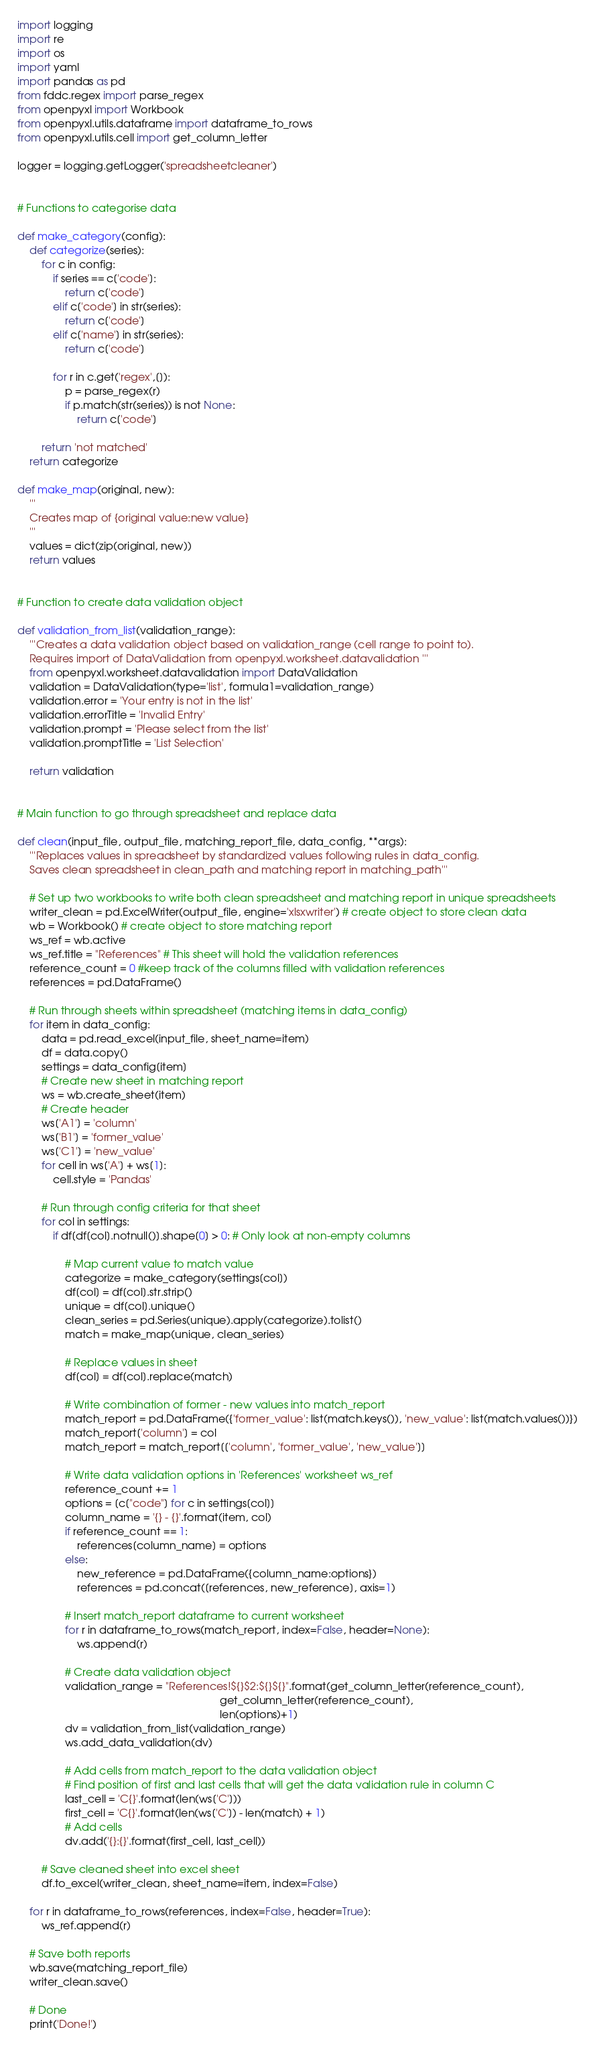<code> <loc_0><loc_0><loc_500><loc_500><_Python_>import logging
import re
import os
import yaml
import pandas as pd
from fddc.regex import parse_regex
from openpyxl import Workbook
from openpyxl.utils.dataframe import dataframe_to_rows
from openpyxl.utils.cell import get_column_letter

logger = logging.getLogger('spreadsheetcleaner')


# Functions to categorise data

def make_category(config):
    def categorize(series):
        for c in config:
            if series == c['code']:
                return c['code']
            elif c['code'] in str(series):
                return c['code']
            elif c['name'] in str(series):
                return c['code']

            for r in c.get('regex',[]):
                p = parse_regex(r)
                if p.match(str(series)) is not None:
                    return c['code']
                
        return 'not matched'
    return categorize

def make_map(original, new):
    '''
    Creates map of {original value:new value}
    '''
    values = dict(zip(original, new))
    return values


# Function to create data validation object

def validation_from_list(validation_range):
    '''Creates a data validation object based on validation_range (cell range to point to). 
    Requires import of DataValidation from openpyxl.worksheet.datavalidation '''
    from openpyxl.worksheet.datavalidation import DataValidation
    validation = DataValidation(type='list', formula1=validation_range)
    validation.error = 'Your entry is not in the list'
    validation.errorTitle = 'Invalid Entry'
    validation.prompt = 'Please select from the list'
    validation.promptTitle = 'List Selection'
    
    return validation


# Main function to go through spreadsheet and replace data

def clean(input_file, output_file, matching_report_file, data_config, **args):
    '''Replaces values in spreadsheet by standardized values following rules in data_config. 
    Saves clean spreadsheet in clean_path and matching report in matching_path'''
    
    # Set up two workbooks to write both clean spreadsheet and matching report in unique spreadsheets
    writer_clean = pd.ExcelWriter(output_file, engine='xlsxwriter') # create object to store clean data
    wb = Workbook() # create object to store matching report
    ws_ref = wb.active
    ws_ref.title = "References" # This sheet will hold the validation references
    reference_count = 0 #keep track of the columns filled with validation references
    references = pd.DataFrame()
    
    # Run through sheets within spreadsheet (matching items in data_config)
    for item in data_config:
        data = pd.read_excel(input_file, sheet_name=item)
        df = data.copy()
        settings = data_config[item]
        # Create new sheet in matching report
        ws = wb.create_sheet(item) 
        # Create header
        ws['A1'] = 'column'
        ws['B1'] = 'former_value'
        ws['C1'] = 'new_value'
        for cell in ws['A'] + ws[1]:
            cell.style = 'Pandas'
            
        # Run through config criteria for that sheet
        for col in settings:
            if df[df[col].notnull()].shape[0] > 0: # Only look at non-empty columns

                # Map current value to match value
                categorize = make_category(settings[col])
                df[col] = df[col].str.strip()
                unique = df[col].unique()
                clean_series = pd.Series(unique).apply(categorize).tolist()
                match = make_map(unique, clean_series)

                # Replace values in sheet
                df[col] = df[col].replace(match)

                # Write combination of former - new values into match_report
                match_report = pd.DataFrame({'former_value': list(match.keys()), 'new_value': list(match.values())})
                match_report['column'] = col
                match_report = match_report[['column', 'former_value', 'new_value']]
                
                # Write data validation options in 'References' worksheet ws_ref
                reference_count += 1
                options = [c["code"] for c in settings[col]]
                column_name = '{} - {}'.format(item, col)
                if reference_count == 1:
                    references[column_name] = options
                else:
                    new_reference = pd.DataFrame({column_name:options})
                    references = pd.concat([references, new_reference], axis=1)
                
                # Insert match_report dataframe to current worksheet
                for r in dataframe_to_rows(match_report, index=False, header=None):
                    ws.append(r)

                # Create data validation object
                validation_range = "References!${}$2:${}${}".format(get_column_letter(reference_count), 
                                                                    get_column_letter(reference_count), 
                                                                    len(options)+1)
                dv = validation_from_list(validation_range)
                ws.add_data_validation(dv)
                
                # Add cells from match_report to the data validation object
                # Find position of first and last cells that will get the data validation rule in column C
                last_cell = 'C{}'.format(len(ws['C']))
                first_cell = 'C{}'.format(len(ws['C']) - len(match) + 1)
                # Add cells
                dv.add('{}:{}'.format(first_cell, last_cell))
               
        # Save cleaned sheet into excel sheet
        df.to_excel(writer_clean, sheet_name=item, index=False)

    for r in dataframe_to_rows(references, index=False, header=True):
        ws_ref.append(r)
    
    # Save both reports
    wb.save(matching_report_file)
    writer_clean.save()
    
    # Done
    print('Done!')</code> 